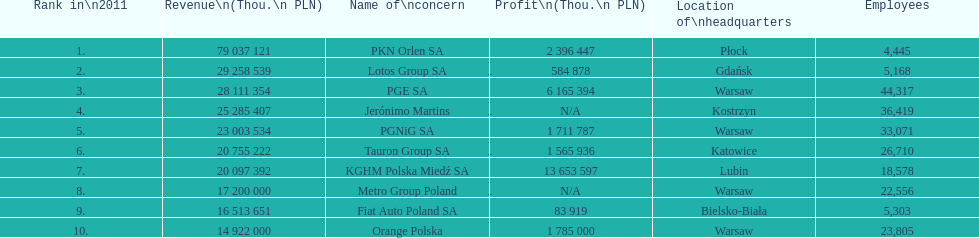What is the number of employees who work for pgnig sa? 33,071. 